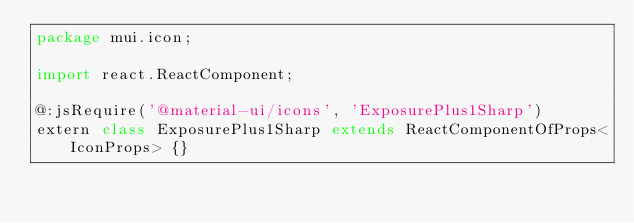<code> <loc_0><loc_0><loc_500><loc_500><_Haxe_>package mui.icon;

import react.ReactComponent;

@:jsRequire('@material-ui/icons', 'ExposurePlus1Sharp')
extern class ExposurePlus1Sharp extends ReactComponentOfProps<IconProps> {}
</code> 